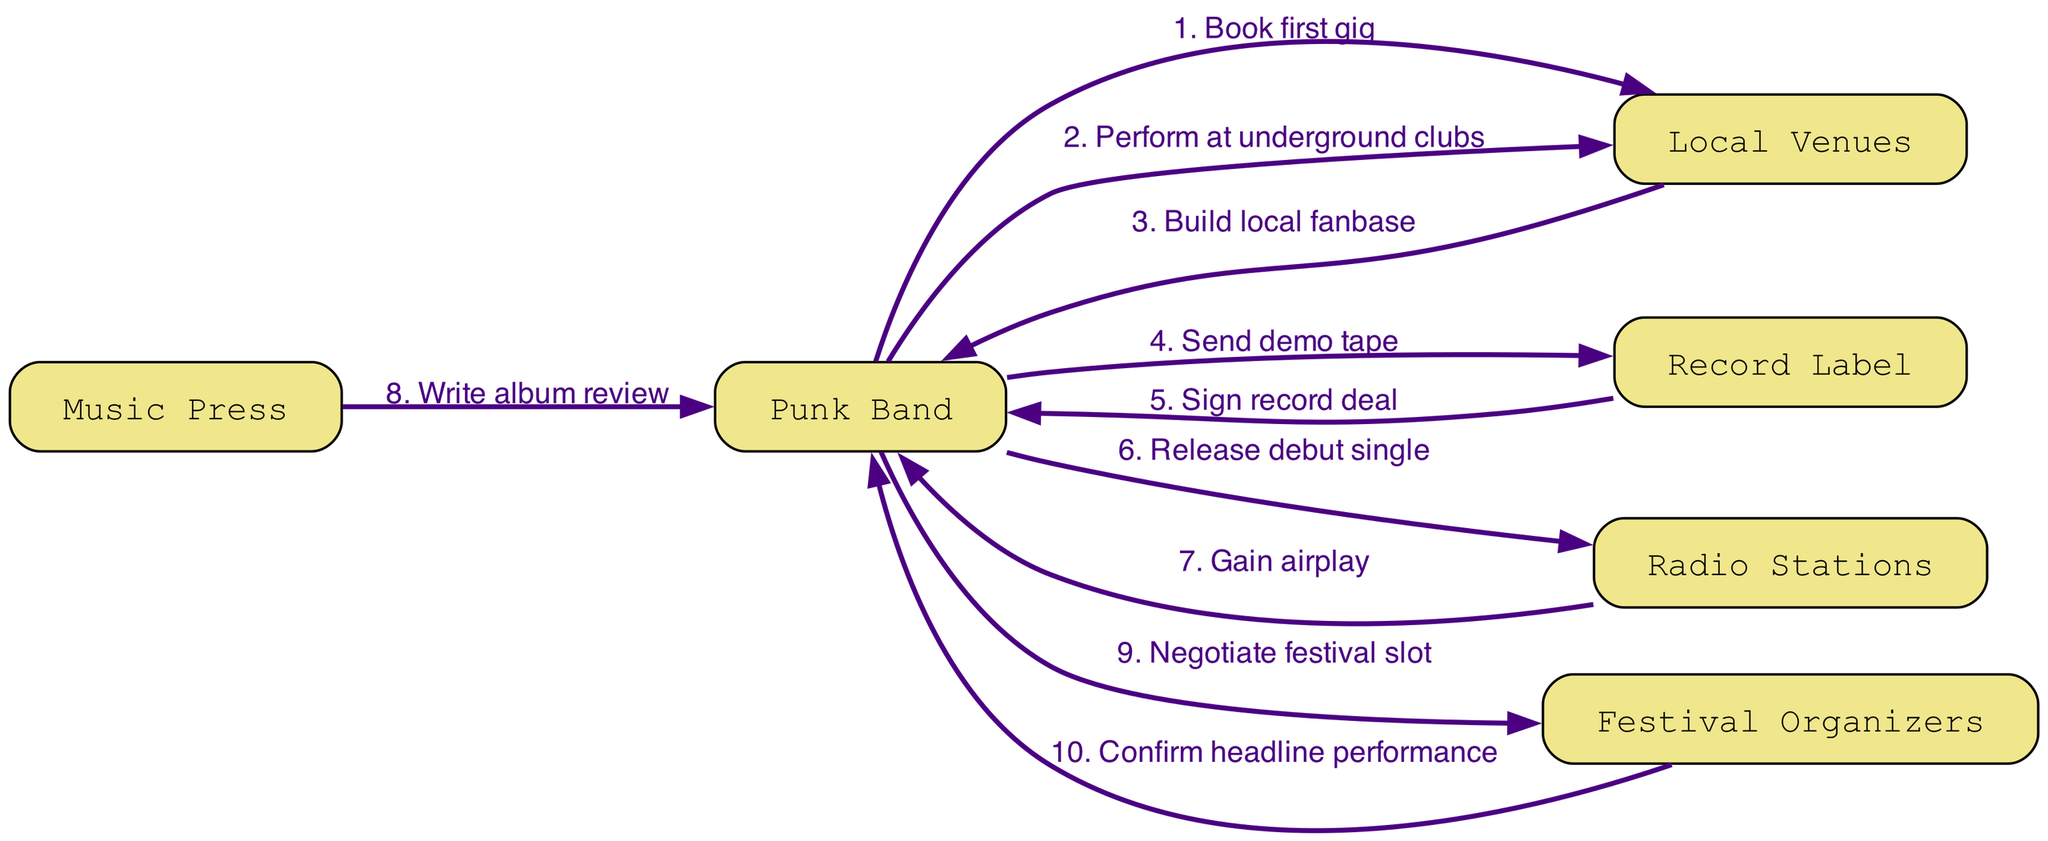What is the first action taken by the Punk Band? The first action in the sequence diagram is identified as "Book first gig," which is the first outlined action initiated by the Punk Band.
Answer: Book first gig How many actors are involved in the sequence? By counting the listed actors in the diagram, we see there are six actors: Punk Band, Local Venues, Record Label, Radio Stations, Music Press, and Festival Organizers.
Answer: 6 Which actor receives the demo tape from the Punk Band? The diagram specifies that the Punk Band sends the demo tape to the Record Label, clearly indicating the recipient of that action.
Answer: Record Label What is the last action before the Punk Band confirms the headline performance? Looking at the sequence of events, the action right before confirming the headline performance is "Negotiate festival slot." This step directly precedes the final performance confirmation in the diagram.
Answer: Negotiate festival slot Which actor provides airplay to the Punk Band's debut single? The sequence shows that the Radio Stations provide airplay to the Punk Band's debut single, which is indicated as a direct interaction from the Radio Stations in the diagram.
Answer: Radio Stations How many edges connect the Punk Band to the Local Venues? The Punk Band has two actions directed towards the Local Venues: "Book first gig" and "Perform at underground clubs." Hence, there are two edges connecting them in the diagram.
Answer: 2 What is the role of the Music Press in the sequence? The Music Press's role is clearly defined as "Write album review," which shows their involvement with the Punk Band following the release of the music.
Answer: Write album review Which action follows the signing of the record deal? The sequence indicates that after the Record Label signs the record deal with the Punk Band, the subsequent action taken by the Punk Band is to "Release debut single." This is the next step in their rise to fame.
Answer: Release debut single What happens after the Radio Stations gain airplay? After the Radio Stations gain airplay, the next step involves the Music Press, which writes an album review of the Punk Band’s work, linking these two actions together in sequence.
Answer: Write album review 